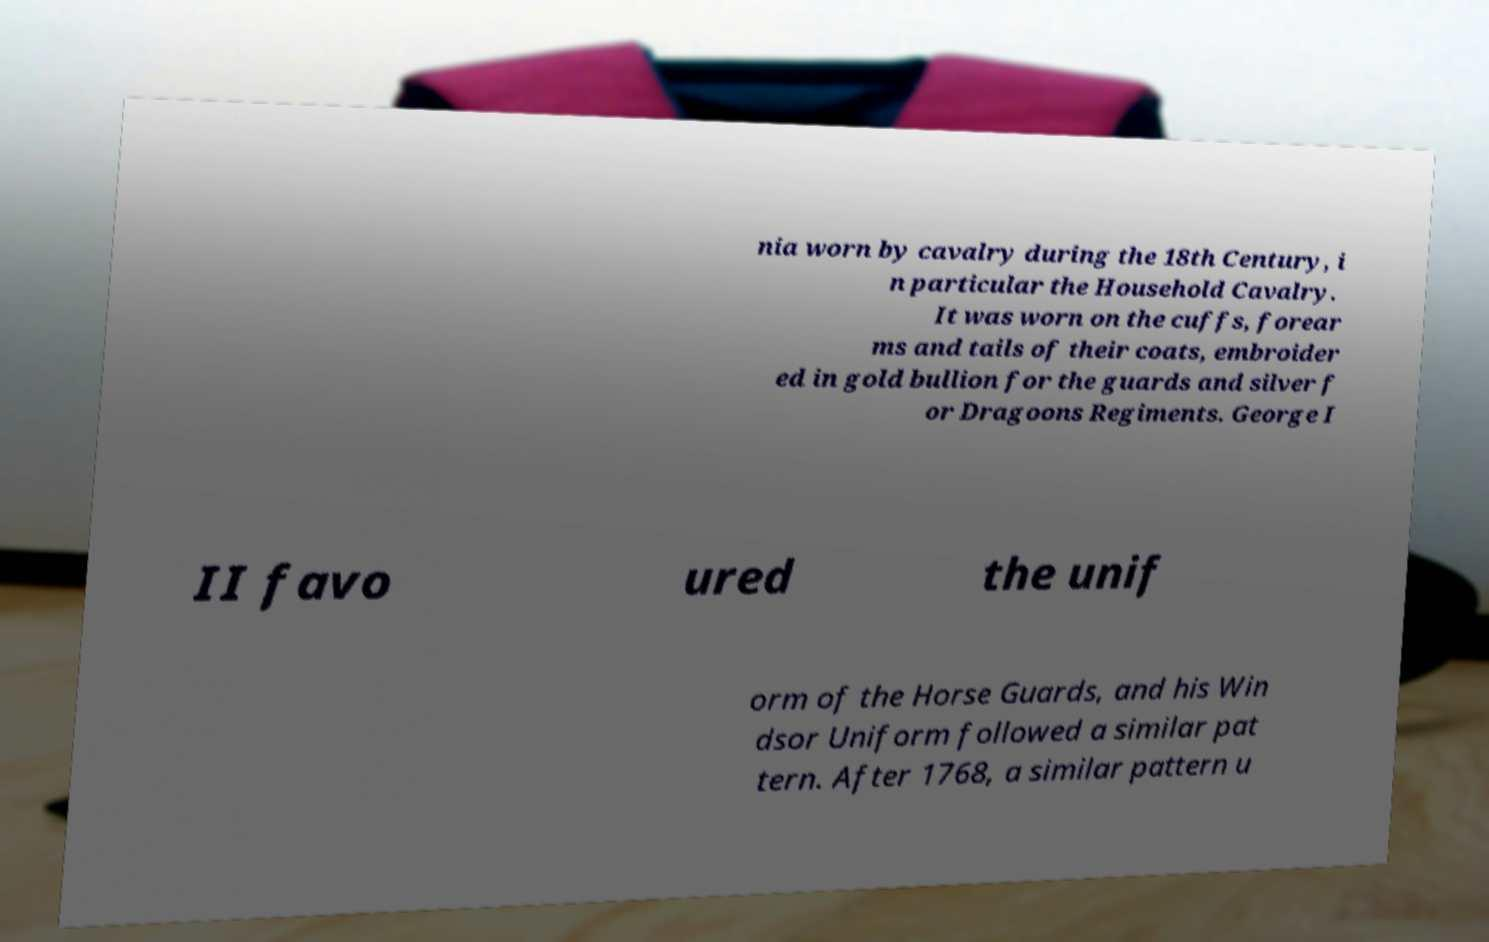Can you accurately transcribe the text from the provided image for me? nia worn by cavalry during the 18th Century, i n particular the Household Cavalry. It was worn on the cuffs, forear ms and tails of their coats, embroider ed in gold bullion for the guards and silver f or Dragoons Regiments. George I II favo ured the unif orm of the Horse Guards, and his Win dsor Uniform followed a similar pat tern. After 1768, a similar pattern u 